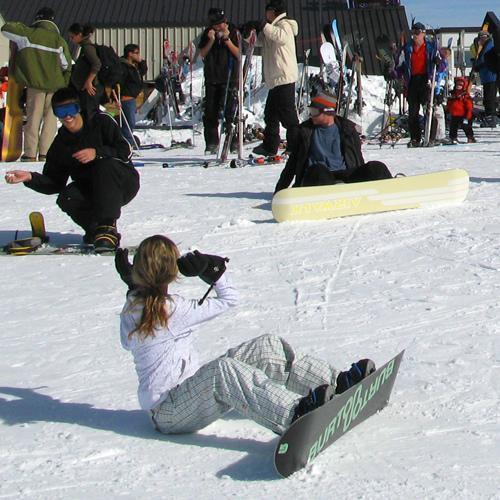What are the people sitting in the snow doing?
From the following four choices, select the correct answer to address the question.
Options: Waiting, sledding, gambling, skiing. Waiting. 